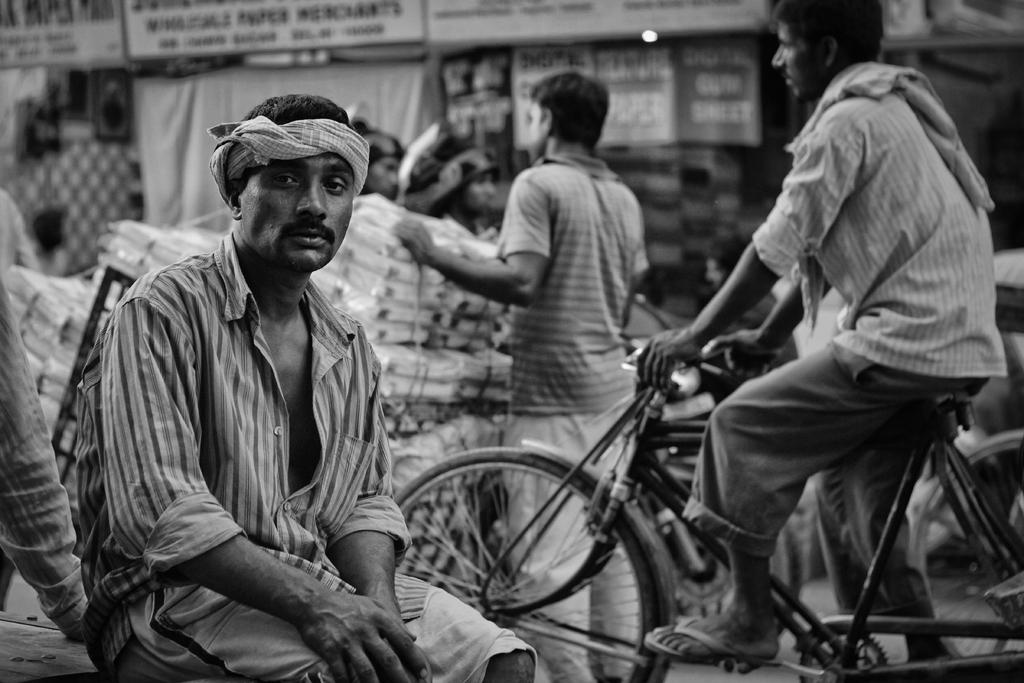What is the color scheme of the image? The image is black and white. What is the main subject of the image? There are three people in the image, one sitting on a bench, one sitting on a bicycle, and one standing and holding things. What objects are present in the image? There are boards present in the image. What type of coil can be seen in the image? There is no coil present in the image. What ingredients are used to make the stew in the image? There is no stew present in the image. 